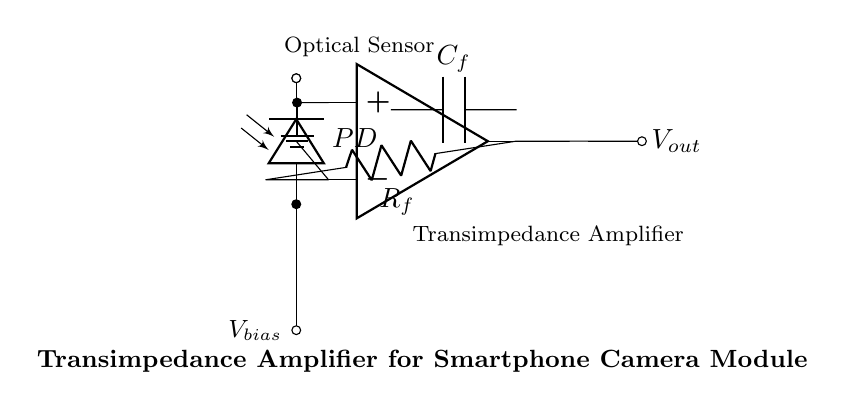What is the main function of the photodiode in this circuit? The photodiode converts light into an electrical current, which is essential for the sensor to detect and process optical signals.
Answer: Light to current conversion What component is used for feedback in the transimpedance amplifier? The resistor labeled R sub f provides feedback in the amplifier configuration, helping to define the gain and converting the output current back to a voltage.
Answer: Resistor What type of sensor is represented in this circuit? The circuit incorporates an optical sensor, as indicated by the label present near the photodiode component in the diagram.
Answer: Optical sensor What voltage level is the non-inverting input of the amplifier connected to? The non-inverting input of the amplifier is connected to the ground, indicating a reference potential of zero volts for the amplifier operation.
Answer: Ground What role does the capacitor play in this circuit? The capacitor labeled C sub f is used to filter high-frequency noise, enhancing the stability and performance of the transimpedance amplifier response.
Answer: Filtering noise What happens to the output voltage when the input light intensity increases? As the light intensity increases, the current generated by the photodiode rises, leading to a corresponding increase in the output voltage due to the transimpedance amplifier's function.
Answer: Increases What kind of signal does the output of the transimpedance amplifier provide? The output voltage from the amplifier is a voltage signal indicative of the amount of light detected by the photodiode, making it a representation of the optical input.
Answer: Voltage signal 